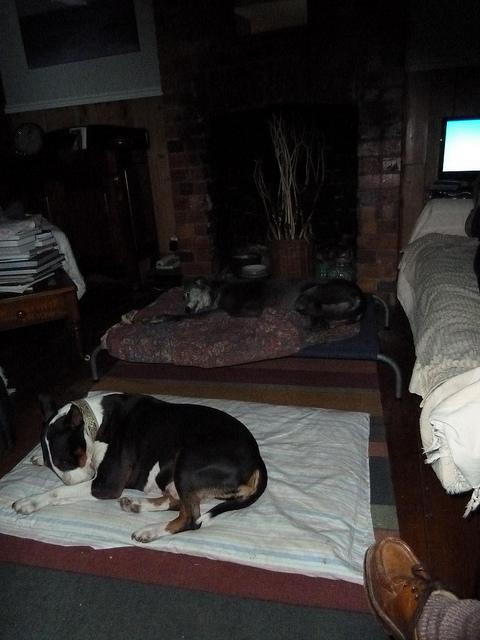What can be built along the back wall?

Choices:
A) snow man
B) gingerbread
C) clothing
D) fire fire 